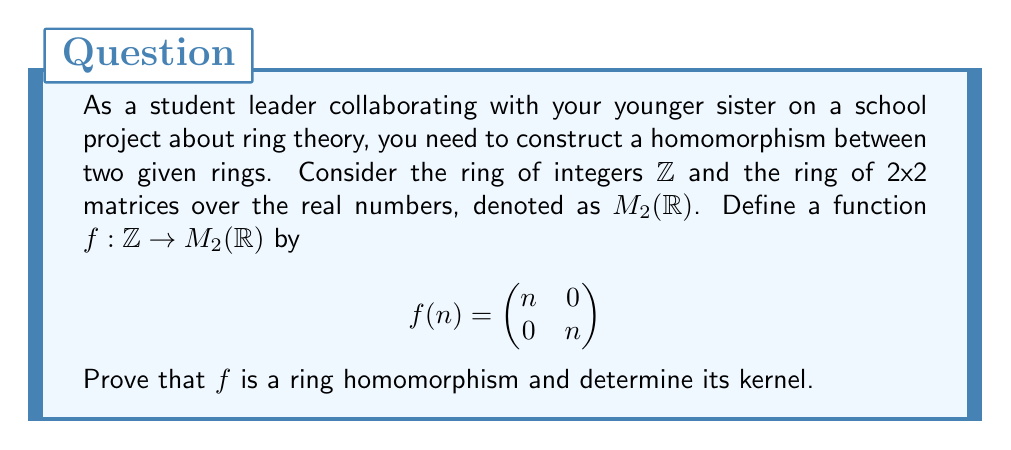Give your solution to this math problem. To prove that $f$ is a ring homomorphism, we need to show that it preserves both addition and multiplication. We also need to show that it maps the identity element of $\mathbb{Z}$ to the identity element of $M_2(\mathbb{R})$.

1. Preserving addition:
Let $a, b \in \mathbb{Z}$. We need to show that $f(a+b) = f(a) + f(b)$.

$$f(a+b) = \begin{pmatrix} a+b & 0 \\ 0 & a+b \end{pmatrix}$$
$$f(a) + f(b) = \begin{pmatrix} a & 0 \\ 0 & a \end{pmatrix} + \begin{pmatrix} b & 0 \\ 0 & b \end{pmatrix} = \begin{pmatrix} a+b & 0 \\ 0 & a+b \end{pmatrix}$$

Thus, $f(a+b) = f(a) + f(b)$.

2. Preserving multiplication:
Let $a, b \in \mathbb{Z}$. We need to show that $f(ab) = f(a)f(b)$.

$$f(ab) = \begin{pmatrix} ab & 0 \\ 0 & ab \end{pmatrix}$$
$$f(a)f(b) = \begin{pmatrix} a & 0 \\ 0 & a \end{pmatrix} \begin{pmatrix} b & 0 \\ 0 & b \end{pmatrix} = \begin{pmatrix} ab & 0 \\ 0 & ab \end{pmatrix}$$

Thus, $f(ab) = f(a)f(b)$.

3. Mapping identity element:
The identity element in $\mathbb{Z}$ is 1, and the identity element in $M_2(\mathbb{R})$ is $\begin{pmatrix} 1 & 0 \\ 0 & 1 \end{pmatrix}$.

$$f(1) = \begin{pmatrix} 1 & 0 \\ 0 & 1 \end{pmatrix}$$

Therefore, $f$ maps the identity element of $\mathbb{Z}$ to the identity element of $M_2(\mathbb{R})$.

Since $f$ satisfies all three conditions, it is a ring homomorphism.

To determine the kernel of $f$, we need to find all elements $n \in \mathbb{Z}$ such that $f(n) = 0_{M_2(\mathbb{R})}$, where $0_{M_2(\mathbb{R})}$ is the zero matrix.

$$f(n) = \begin{pmatrix} n & 0 \\ 0 & n \end{pmatrix} = \begin{pmatrix} 0 & 0 \\ 0 & 0 \end{pmatrix}$$

This is only true when $n = 0$. Therefore, the kernel of $f$ is $\{0\}$.
Answer: $f$ is a ring homomorphism, and its kernel is $\{0\}$. 